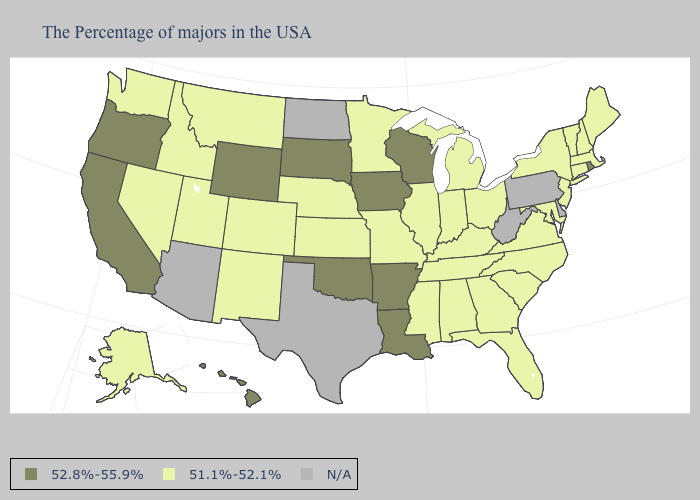Which states have the lowest value in the MidWest?
Quick response, please. Ohio, Michigan, Indiana, Illinois, Missouri, Minnesota, Kansas, Nebraska. Name the states that have a value in the range 51.1%-52.1%?
Give a very brief answer. Maine, Massachusetts, New Hampshire, Vermont, Connecticut, New York, New Jersey, Maryland, Virginia, North Carolina, South Carolina, Ohio, Florida, Georgia, Michigan, Kentucky, Indiana, Alabama, Tennessee, Illinois, Mississippi, Missouri, Minnesota, Kansas, Nebraska, Colorado, New Mexico, Utah, Montana, Idaho, Nevada, Washington, Alaska. Name the states that have a value in the range 52.8%-55.9%?
Keep it brief. Rhode Island, Wisconsin, Louisiana, Arkansas, Iowa, Oklahoma, South Dakota, Wyoming, California, Oregon, Hawaii. Does Missouri have the lowest value in the MidWest?
Be succinct. Yes. Which states have the highest value in the USA?
Give a very brief answer. Rhode Island, Wisconsin, Louisiana, Arkansas, Iowa, Oklahoma, South Dakota, Wyoming, California, Oregon, Hawaii. Name the states that have a value in the range 52.8%-55.9%?
Be succinct. Rhode Island, Wisconsin, Louisiana, Arkansas, Iowa, Oklahoma, South Dakota, Wyoming, California, Oregon, Hawaii. Which states have the highest value in the USA?
Be succinct. Rhode Island, Wisconsin, Louisiana, Arkansas, Iowa, Oklahoma, South Dakota, Wyoming, California, Oregon, Hawaii. Which states have the highest value in the USA?
Concise answer only. Rhode Island, Wisconsin, Louisiana, Arkansas, Iowa, Oklahoma, South Dakota, Wyoming, California, Oregon, Hawaii. Does California have the lowest value in the USA?
Answer briefly. No. Which states have the highest value in the USA?
Answer briefly. Rhode Island, Wisconsin, Louisiana, Arkansas, Iowa, Oklahoma, South Dakota, Wyoming, California, Oregon, Hawaii. Does Oklahoma have the lowest value in the South?
Keep it brief. No. What is the highest value in the South ?
Concise answer only. 52.8%-55.9%. What is the value of Missouri?
Give a very brief answer. 51.1%-52.1%. Name the states that have a value in the range N/A?
Write a very short answer. Delaware, Pennsylvania, West Virginia, Texas, North Dakota, Arizona. 